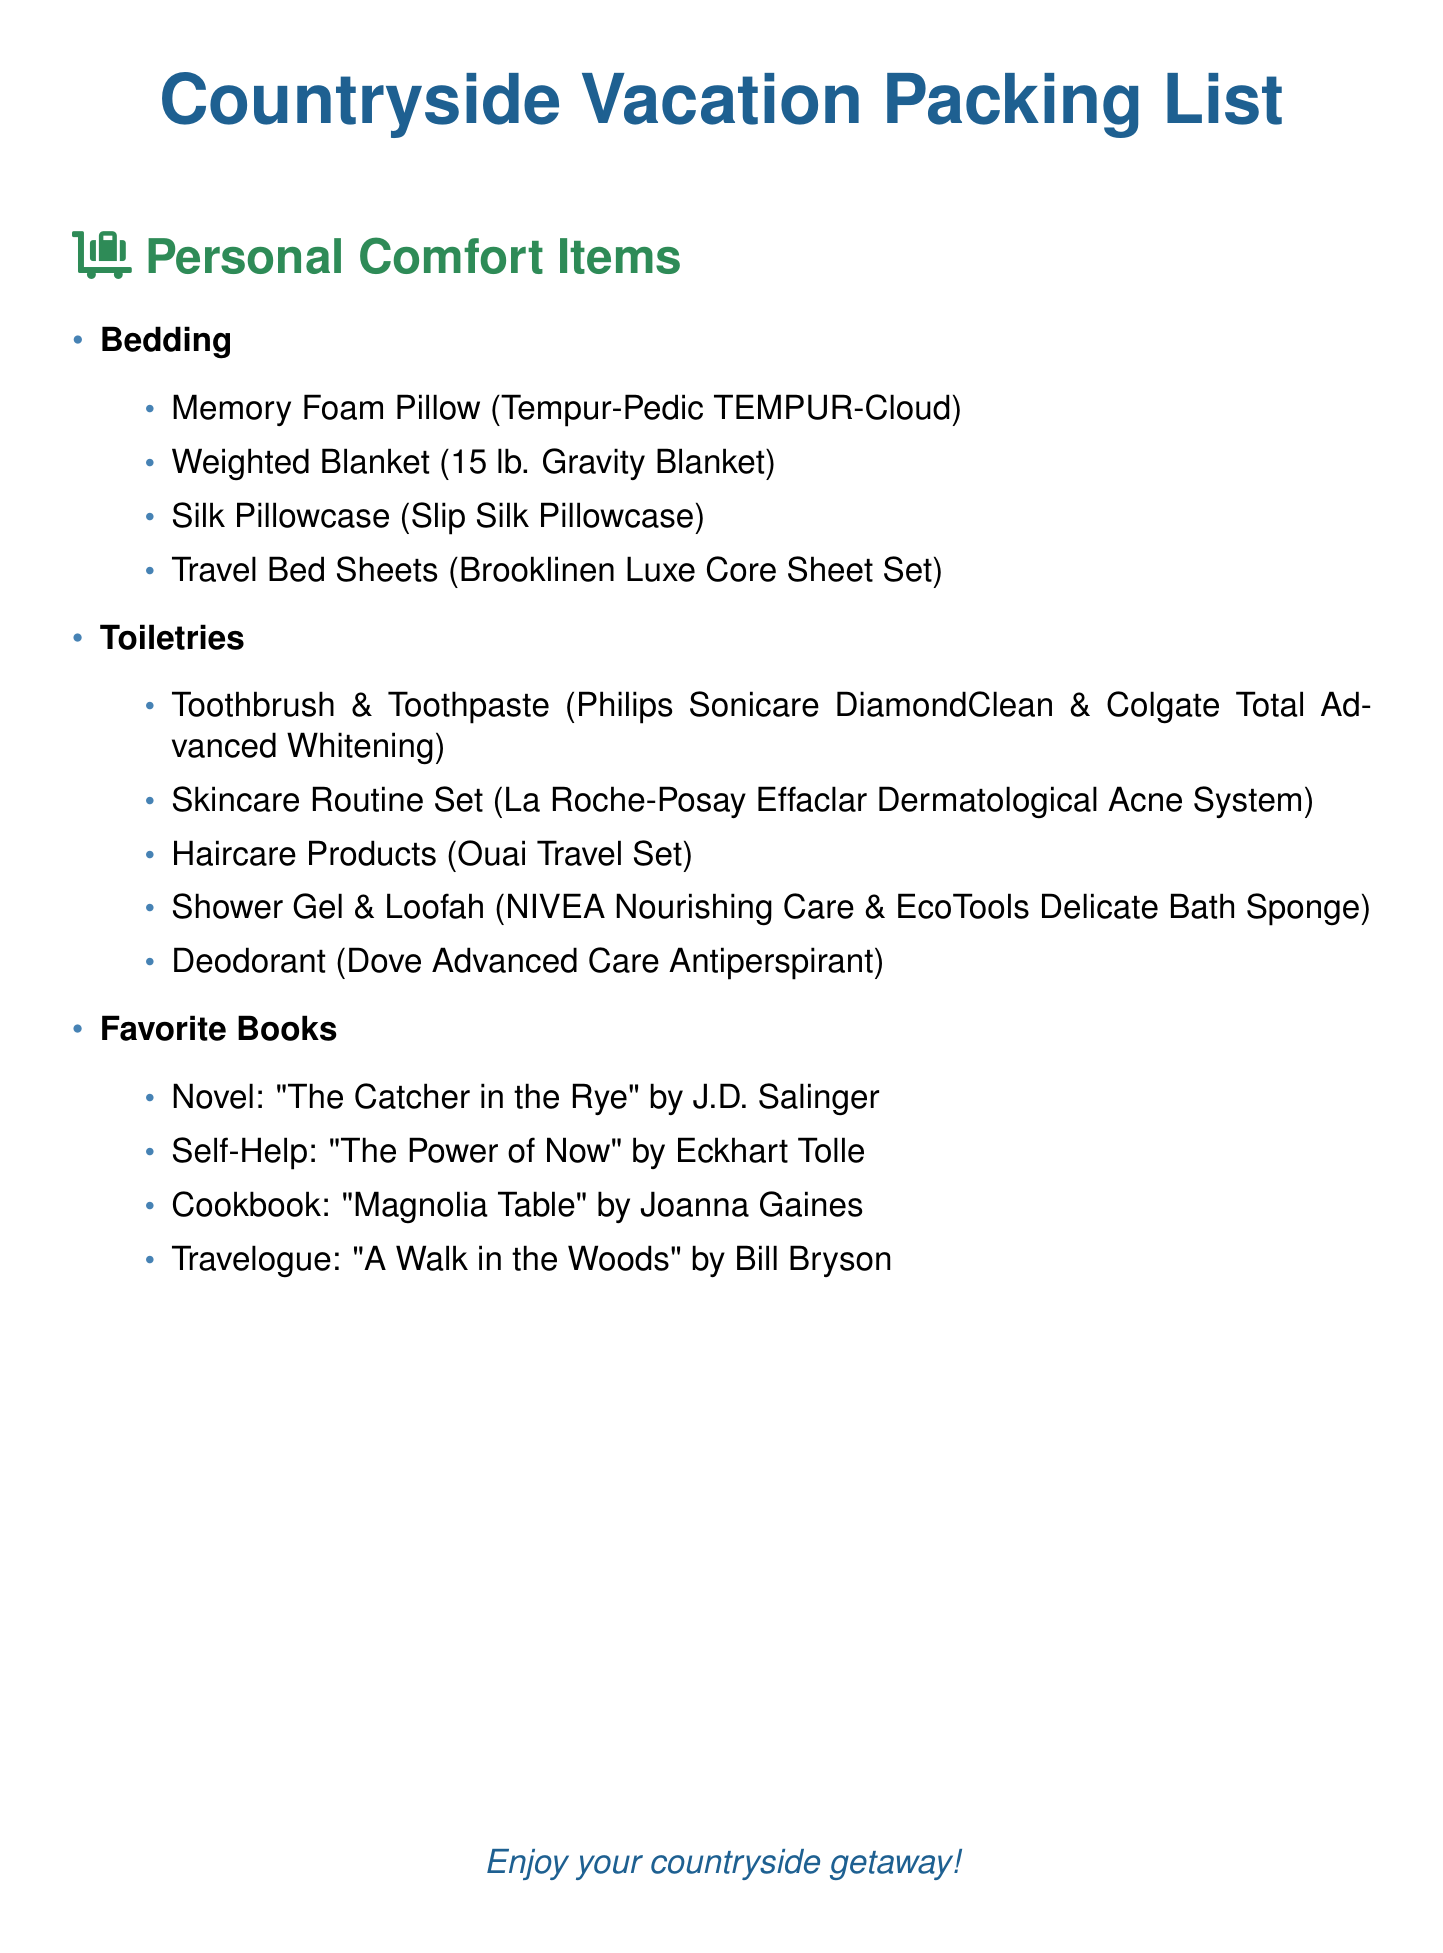What type of pillow is listed? The document specifies a Memory Foam Pillow, which is a type of pillow designed for comfort and support.
Answer: Memory Foam Pillow What is the weight of the weighted blanket? The document mentions that the weighted blanket weighs 15 pounds, providing comfort and coziness.
Answer: 15 lb Which brand is mentioned for the toothbrush? The document lists Philips Sonicare as the brand for the toothbrush, indicating a quality choice for dental care.
Answer: Philips Sonicare How many books are listed in the Favorite Books section? The document contains a total of four books listed under the Favorite Books category for reading enjoyment.
Answer: 4 Which skincare set is included? The document highlights La Roche-Posay as the brand for the skincare routine set, relevant for maintaining skin health.
Answer: La Roche-Posay Effaclar Dermatological Acne System What type of gel is included under toiletries? The document specifies NIVEA Nourishing Care as the type of shower gel included for personal hygiene.
Answer: Shower Gel What is the title of the self-help book listed? The document denotes "The Power of Now" as the self-help book, indicating its relevance for mindfulness and personal growth.
Answer: The Power of Now What type of bedding is mentioned aside from pillows? The document mentions a weighted blanket as an additional bedding item for comfort.
Answer: Weighted Blanket What type of loofah is listed in toiletries? The document refers to EcoTools Delicate Bath Sponge as the type of loofah for bathing.
Answer: EcoTools Delicate Bath Sponge 